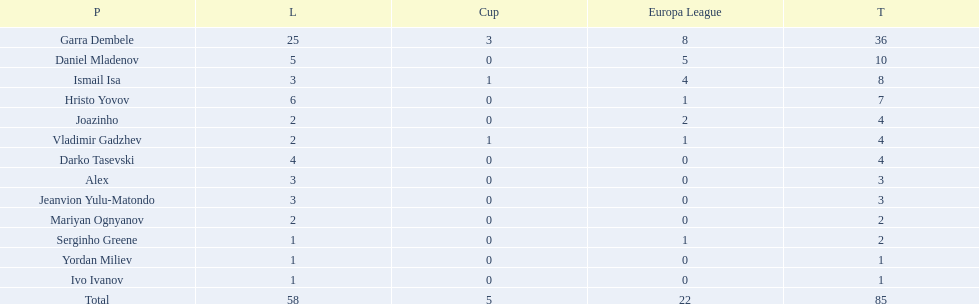Who had the most goal scores? Garra Dembele. 